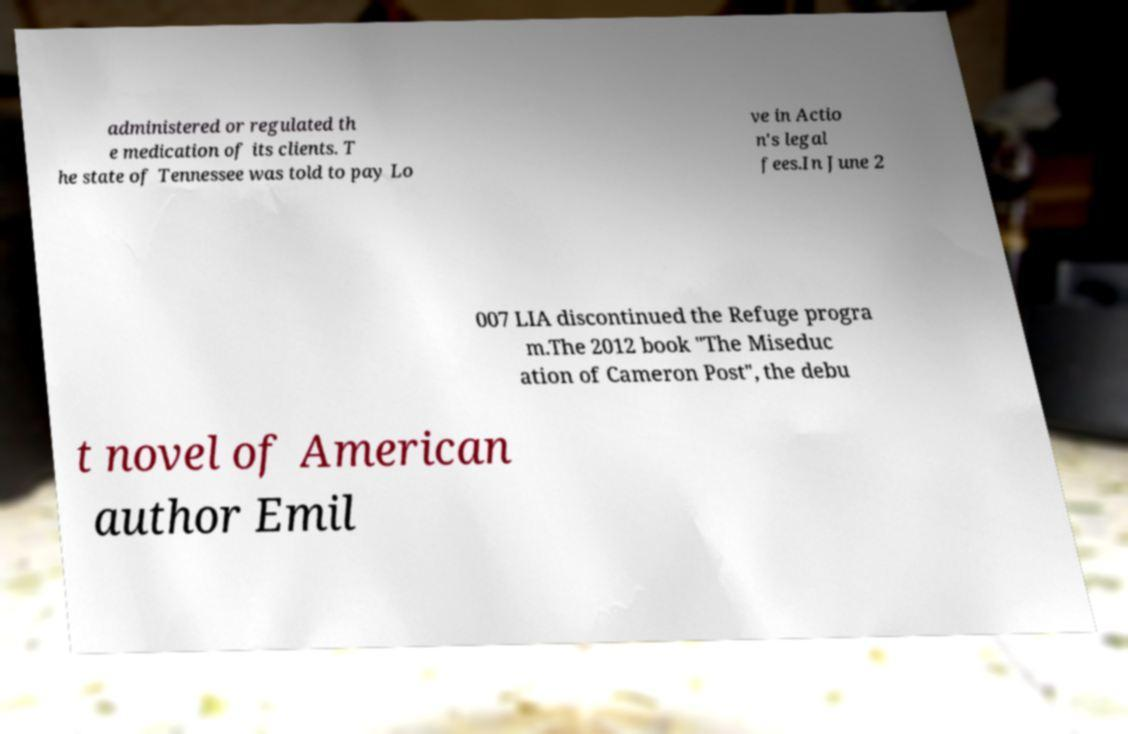Could you extract and type out the text from this image? administered or regulated th e medication of its clients. T he state of Tennessee was told to pay Lo ve in Actio n's legal fees.In June 2 007 LIA discontinued the Refuge progra m.The 2012 book "The Miseduc ation of Cameron Post", the debu t novel of American author Emil 